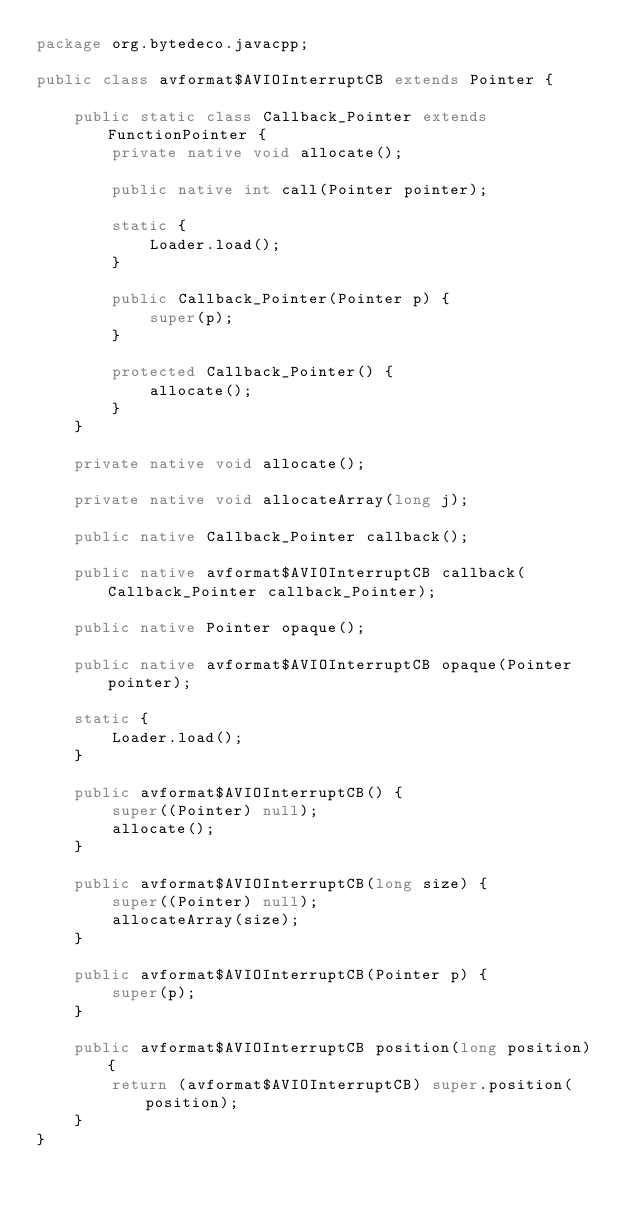Convert code to text. <code><loc_0><loc_0><loc_500><loc_500><_Java_>package org.bytedeco.javacpp;

public class avformat$AVIOInterruptCB extends Pointer {

    public static class Callback_Pointer extends FunctionPointer {
        private native void allocate();

        public native int call(Pointer pointer);

        static {
            Loader.load();
        }

        public Callback_Pointer(Pointer p) {
            super(p);
        }

        protected Callback_Pointer() {
            allocate();
        }
    }

    private native void allocate();

    private native void allocateArray(long j);

    public native Callback_Pointer callback();

    public native avformat$AVIOInterruptCB callback(Callback_Pointer callback_Pointer);

    public native Pointer opaque();

    public native avformat$AVIOInterruptCB opaque(Pointer pointer);

    static {
        Loader.load();
    }

    public avformat$AVIOInterruptCB() {
        super((Pointer) null);
        allocate();
    }

    public avformat$AVIOInterruptCB(long size) {
        super((Pointer) null);
        allocateArray(size);
    }

    public avformat$AVIOInterruptCB(Pointer p) {
        super(p);
    }

    public avformat$AVIOInterruptCB position(long position) {
        return (avformat$AVIOInterruptCB) super.position(position);
    }
}
</code> 